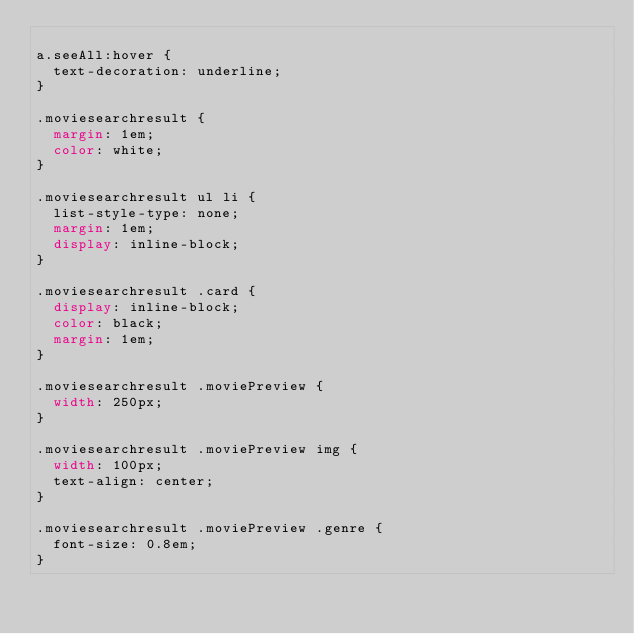Convert code to text. <code><loc_0><loc_0><loc_500><loc_500><_CSS_>
a.seeAll:hover {
  text-decoration: underline;
}

.moviesearchresult {
  margin: 1em;
  color: white;
}

.moviesearchresult ul li {
  list-style-type: none;
  margin: 1em;
  display: inline-block;
}

.moviesearchresult .card {
  display: inline-block;
  color: black;
  margin: 1em;
}

.moviesearchresult .moviePreview {
  width: 250px;
}

.moviesearchresult .moviePreview img {
  width: 100px;
  text-align: center;
}

.moviesearchresult .moviePreview .genre {
  font-size: 0.8em;
}
</code> 